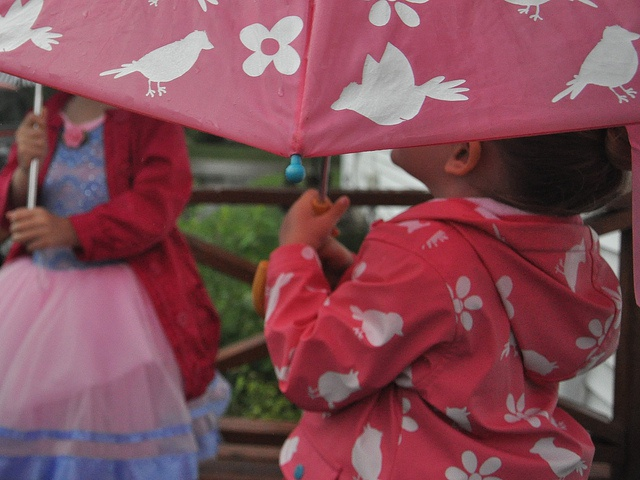Describe the objects in this image and their specific colors. I can see people in salmon, maroon, brown, and black tones, umbrella in salmon, brown, darkgray, and lightgray tones, people in salmon, maroon, gray, and brown tones, bird in salmon, darkgray, brown, and gray tones, and bird in salmon, lightgray, and darkgray tones in this image. 